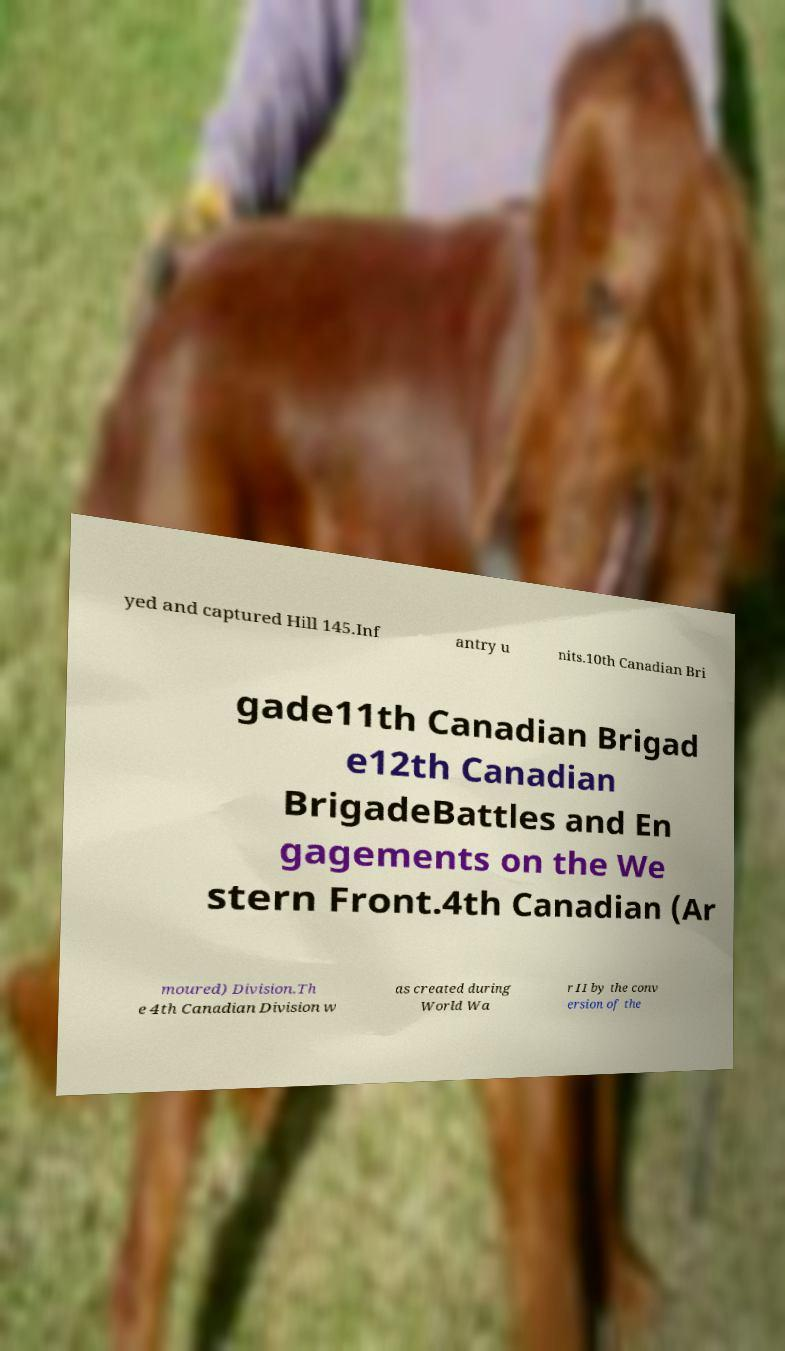What messages or text are displayed in this image? I need them in a readable, typed format. yed and captured Hill 145.Inf antry u nits.10th Canadian Bri gade11th Canadian Brigad e12th Canadian BrigadeBattles and En gagements on the We stern Front.4th Canadian (Ar moured) Division.Th e 4th Canadian Division w as created during World Wa r II by the conv ersion of the 